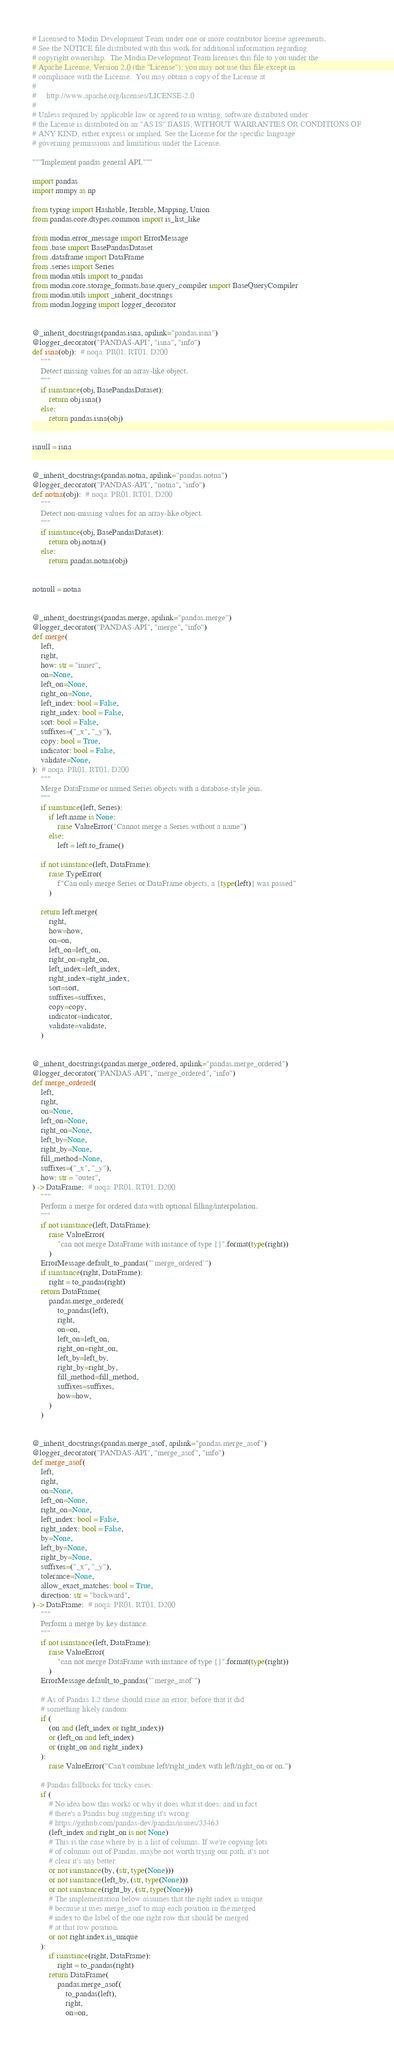Convert code to text. <code><loc_0><loc_0><loc_500><loc_500><_Python_># Licensed to Modin Development Team under one or more contributor license agreements.
# See the NOTICE file distributed with this work for additional information regarding
# copyright ownership.  The Modin Development Team licenses this file to you under the
# Apache License, Version 2.0 (the "License"); you may not use this file except in
# compliance with the License.  You may obtain a copy of the License at
#
#     http://www.apache.org/licenses/LICENSE-2.0
#
# Unless required by applicable law or agreed to in writing, software distributed under
# the License is distributed on an "AS IS" BASIS, WITHOUT WARRANTIES OR CONDITIONS OF
# ANY KIND, either express or implied. See the License for the specific language
# governing permissions and limitations under the License.

"""Implement pandas general API."""

import pandas
import numpy as np

from typing import Hashable, Iterable, Mapping, Union
from pandas.core.dtypes.common import is_list_like

from modin.error_message import ErrorMessage
from .base import BasePandasDataset
from .dataframe import DataFrame
from .series import Series
from modin.utils import to_pandas
from modin.core.storage_formats.base.query_compiler import BaseQueryCompiler
from modin.utils import _inherit_docstrings
from modin.logging import logger_decorator


@_inherit_docstrings(pandas.isna, apilink="pandas.isna")
@logger_decorator("PANDAS-API", "isna", "info")
def isna(obj):  # noqa: PR01, RT01, D200
    """
    Detect missing values for an array-like object.
    """
    if isinstance(obj, BasePandasDataset):
        return obj.isna()
    else:
        return pandas.isna(obj)


isnull = isna


@_inherit_docstrings(pandas.notna, apilink="pandas.notna")
@logger_decorator("PANDAS-API", "notna", "info")
def notna(obj):  # noqa: PR01, RT01, D200
    """
    Detect non-missing values for an array-like object.
    """
    if isinstance(obj, BasePandasDataset):
        return obj.notna()
    else:
        return pandas.notna(obj)


notnull = notna


@_inherit_docstrings(pandas.merge, apilink="pandas.merge")
@logger_decorator("PANDAS-API", "merge", "info")
def merge(
    left,
    right,
    how: str = "inner",
    on=None,
    left_on=None,
    right_on=None,
    left_index: bool = False,
    right_index: bool = False,
    sort: bool = False,
    suffixes=("_x", "_y"),
    copy: bool = True,
    indicator: bool = False,
    validate=None,
):  # noqa: PR01, RT01, D200
    """
    Merge DataFrame or named Series objects with a database-style join.
    """
    if isinstance(left, Series):
        if left.name is None:
            raise ValueError("Cannot merge a Series without a name")
        else:
            left = left.to_frame()

    if not isinstance(left, DataFrame):
        raise TypeError(
            f"Can only merge Series or DataFrame objects, a {type(left)} was passed"
        )

    return left.merge(
        right,
        how=how,
        on=on,
        left_on=left_on,
        right_on=right_on,
        left_index=left_index,
        right_index=right_index,
        sort=sort,
        suffixes=suffixes,
        copy=copy,
        indicator=indicator,
        validate=validate,
    )


@_inherit_docstrings(pandas.merge_ordered, apilink="pandas.merge_ordered")
@logger_decorator("PANDAS-API", "merge_ordered", "info")
def merge_ordered(
    left,
    right,
    on=None,
    left_on=None,
    right_on=None,
    left_by=None,
    right_by=None,
    fill_method=None,
    suffixes=("_x", "_y"),
    how: str = "outer",
) -> DataFrame:  # noqa: PR01, RT01, D200
    """
    Perform a merge for ordered data with optional filling/interpolation.
    """
    if not isinstance(left, DataFrame):
        raise ValueError(
            "can not merge DataFrame with instance of type {}".format(type(right))
        )
    ErrorMessage.default_to_pandas("`merge_ordered`")
    if isinstance(right, DataFrame):
        right = to_pandas(right)
    return DataFrame(
        pandas.merge_ordered(
            to_pandas(left),
            right,
            on=on,
            left_on=left_on,
            right_on=right_on,
            left_by=left_by,
            right_by=right_by,
            fill_method=fill_method,
            suffixes=suffixes,
            how=how,
        )
    )


@_inherit_docstrings(pandas.merge_asof, apilink="pandas.merge_asof")
@logger_decorator("PANDAS-API", "merge_asof", "info")
def merge_asof(
    left,
    right,
    on=None,
    left_on=None,
    right_on=None,
    left_index: bool = False,
    right_index: bool = False,
    by=None,
    left_by=None,
    right_by=None,
    suffixes=("_x", "_y"),
    tolerance=None,
    allow_exact_matches: bool = True,
    direction: str = "backward",
) -> DataFrame:  # noqa: PR01, RT01, D200
    """
    Perform a merge by key distance.
    """
    if not isinstance(left, DataFrame):
        raise ValueError(
            "can not merge DataFrame with instance of type {}".format(type(right))
        )
    ErrorMessage.default_to_pandas("`merge_asof`")

    # As of Pandas 1.2 these should raise an error; before that it did
    # something likely random:
    if (
        (on and (left_index or right_index))
        or (left_on and left_index)
        or (right_on and right_index)
    ):
        raise ValueError("Can't combine left/right_index with left/right_on or on.")

    # Pandas fallbacks for tricky cases:
    if (
        # No idea how this works or why it does what it does; and in fact
        # there's a Pandas bug suggesting it's wrong:
        # https://github.com/pandas-dev/pandas/issues/33463
        (left_index and right_on is not None)
        # This is the case where by is a list of columns. If we're copying lots
        # of columns out of Pandas, maybe not worth trying our path, it's not
        # clear it's any better:
        or not isinstance(by, (str, type(None)))
        or not isinstance(left_by, (str, type(None)))
        or not isinstance(right_by, (str, type(None)))
        # The implementation below assumes that the right index is unique
        # because it uses merge_asof to map each position in the merged
        # index to the label of the one right row that should be merged
        # at that row position.
        or not right.index.is_unique
    ):
        if isinstance(right, DataFrame):
            right = to_pandas(right)
        return DataFrame(
            pandas.merge_asof(
                to_pandas(left),
                right,
                on=on,</code> 